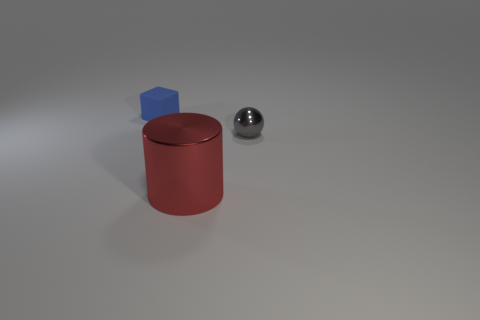Add 1 gray spheres. How many objects exist? 4 Subtract all blocks. How many objects are left? 2 Subtract 0 purple spheres. How many objects are left? 3 Subtract all spheres. Subtract all rubber things. How many objects are left? 1 Add 1 blue blocks. How many blue blocks are left? 2 Add 3 matte cylinders. How many matte cylinders exist? 3 